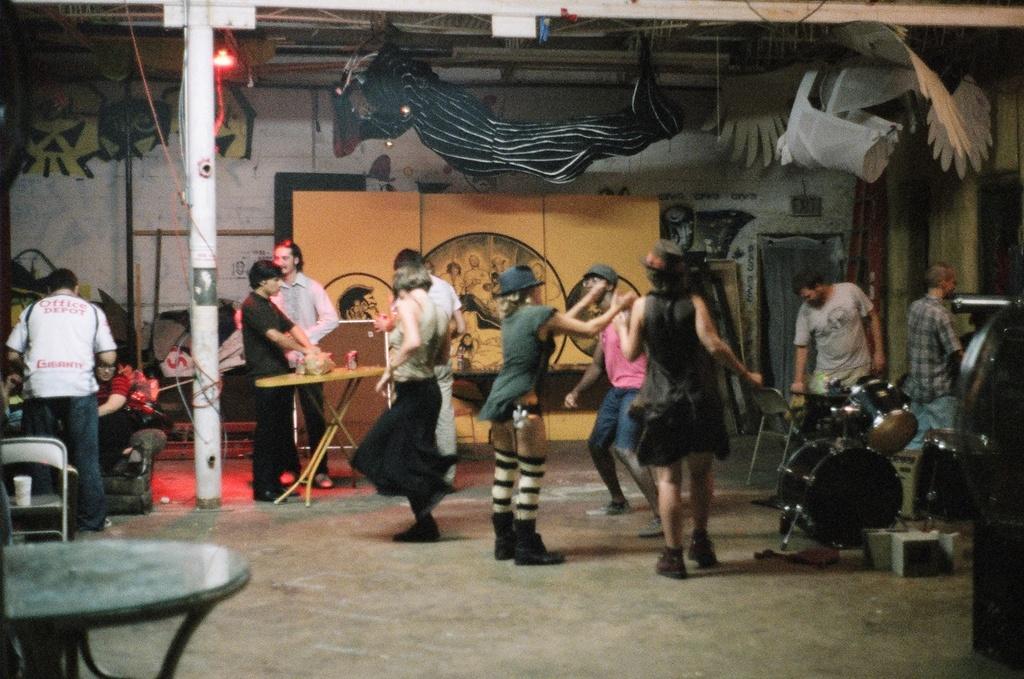In one or two sentences, can you explain what this image depicts? In this image there are group of persons dancing and at the background there are different paintings on the wall. 